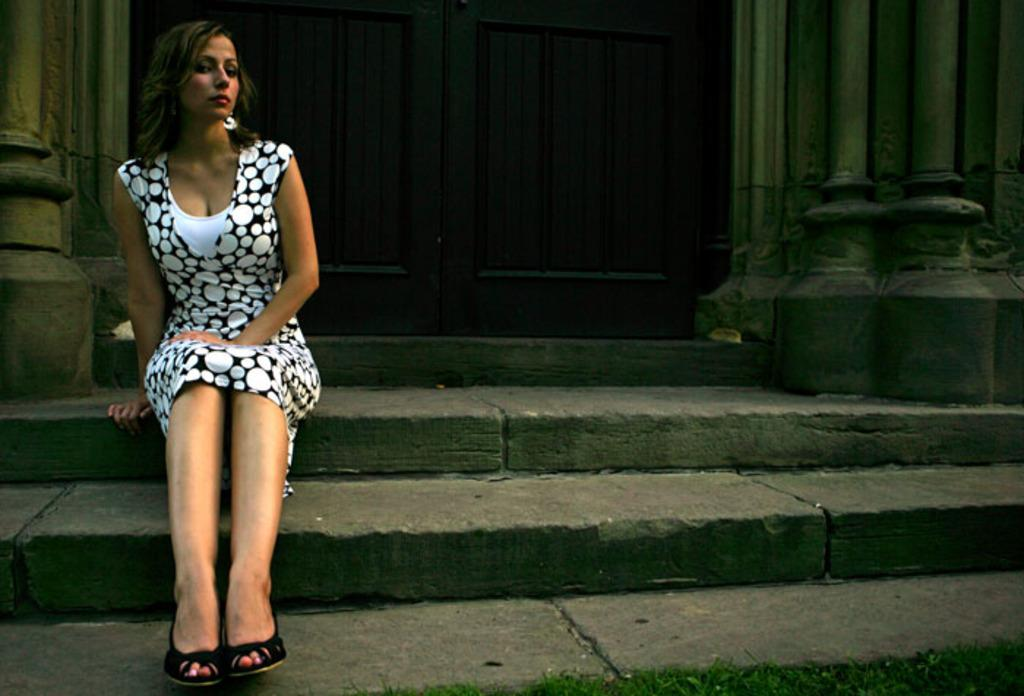What is the lady in the image doing? The lady is sitting on the stairs in the image. What architectural features can be seen in the image? There are doors and pillars visible in the image. How many chairs are present in the image? There are no chairs visible in the image. Is there a tree growing in the middle of the stairs? There is no tree present in the image; it only features a lady sitting on the stairs, doors, and pillars. 